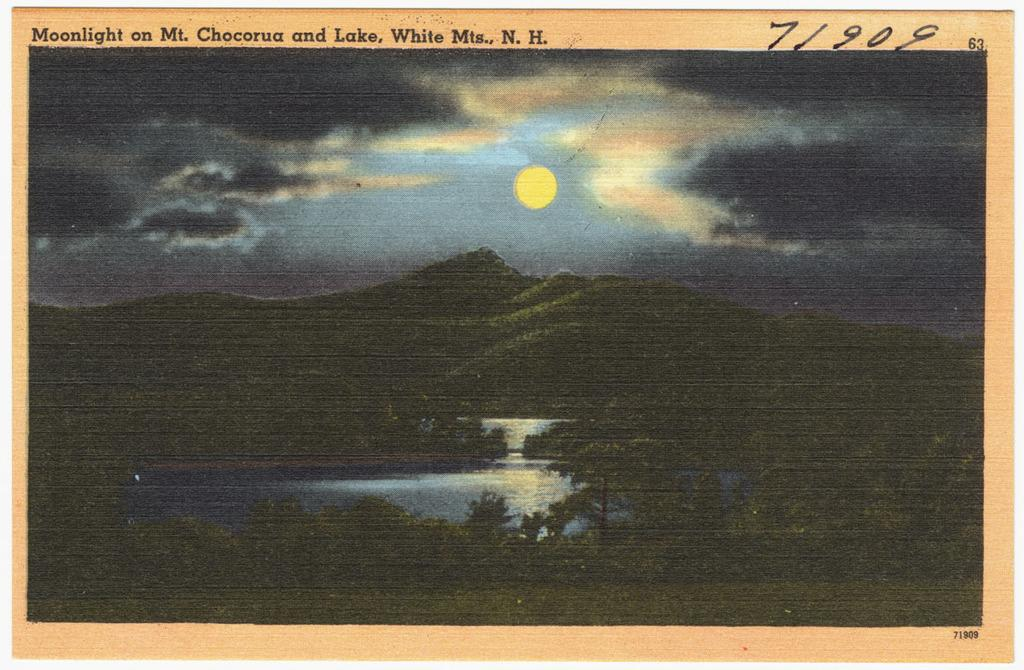What type of vegetation can be seen in the image? There are trees in the image. What natural element is visible in the image besides the trees? There is water visible in the image. How would you describe the sky in the image? The sky is cloudy in the image. Despite the cloudy sky, what can still be seen in the sky? The sun is visible in the sky. Where is the father in the image? There is no father present in the image. How many cats can be seen playing in the water in the image? There are no cats present in the image. 